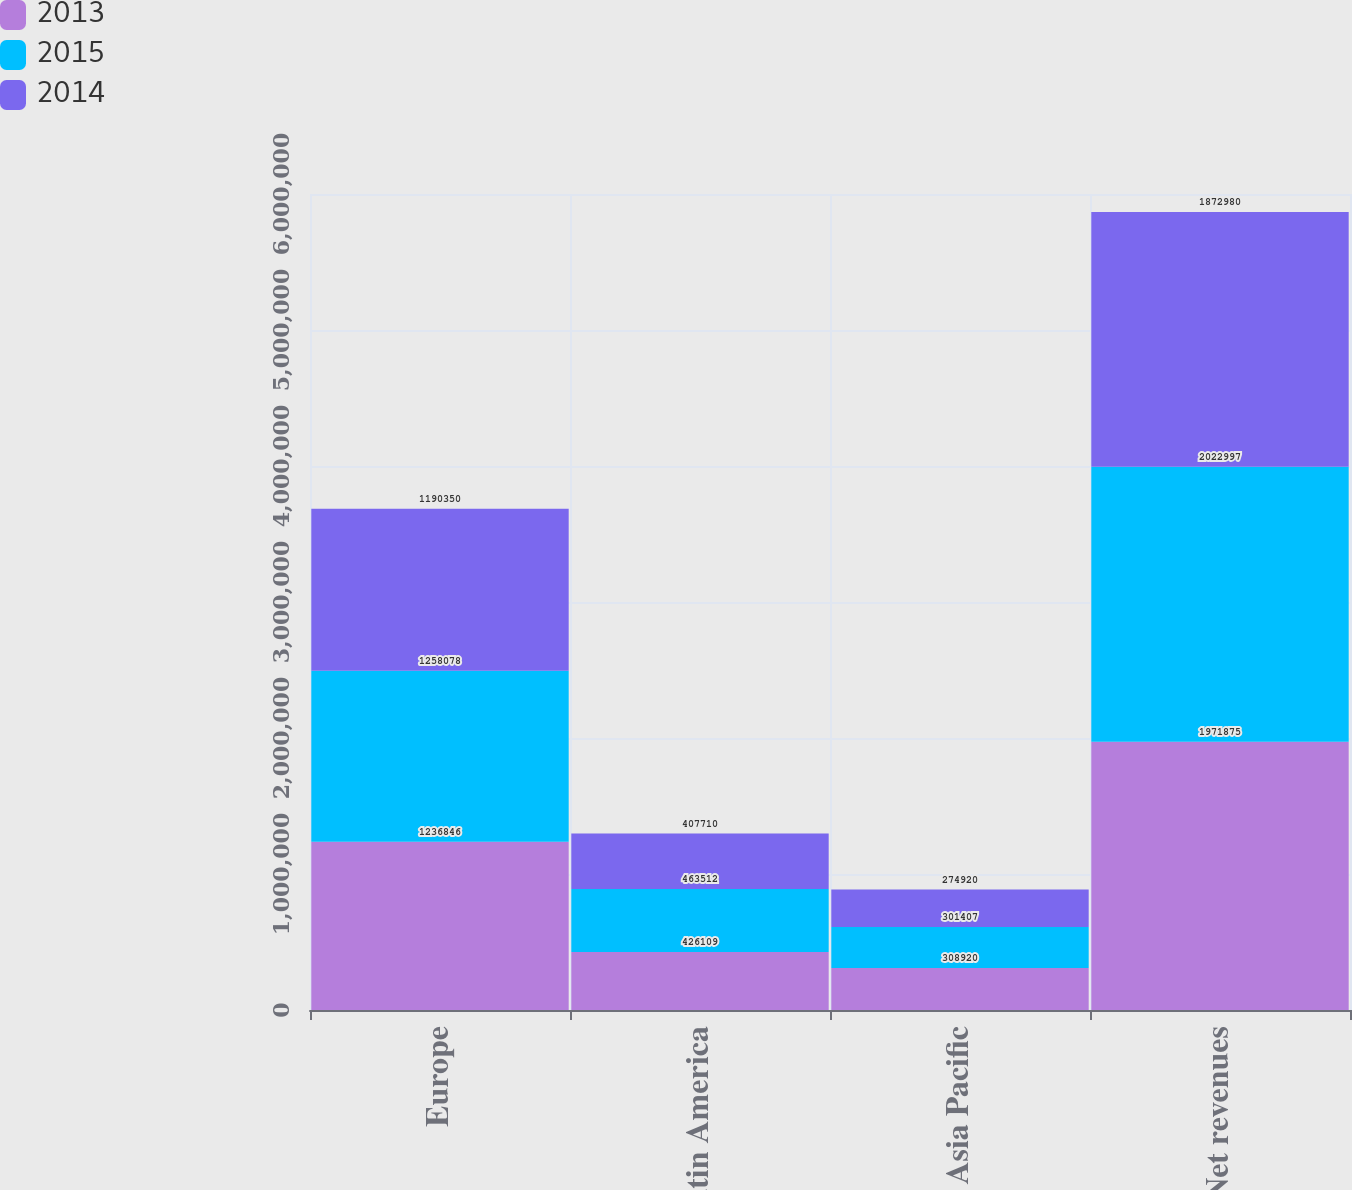Convert chart. <chart><loc_0><loc_0><loc_500><loc_500><stacked_bar_chart><ecel><fcel>Europe<fcel>Latin America<fcel>Asia Pacific<fcel>Net revenues<nl><fcel>2013<fcel>1.23685e+06<fcel>426109<fcel>308920<fcel>1.97188e+06<nl><fcel>2015<fcel>1.25808e+06<fcel>463512<fcel>301407<fcel>2.023e+06<nl><fcel>2014<fcel>1.19035e+06<fcel>407710<fcel>274920<fcel>1.87298e+06<nl></chart> 